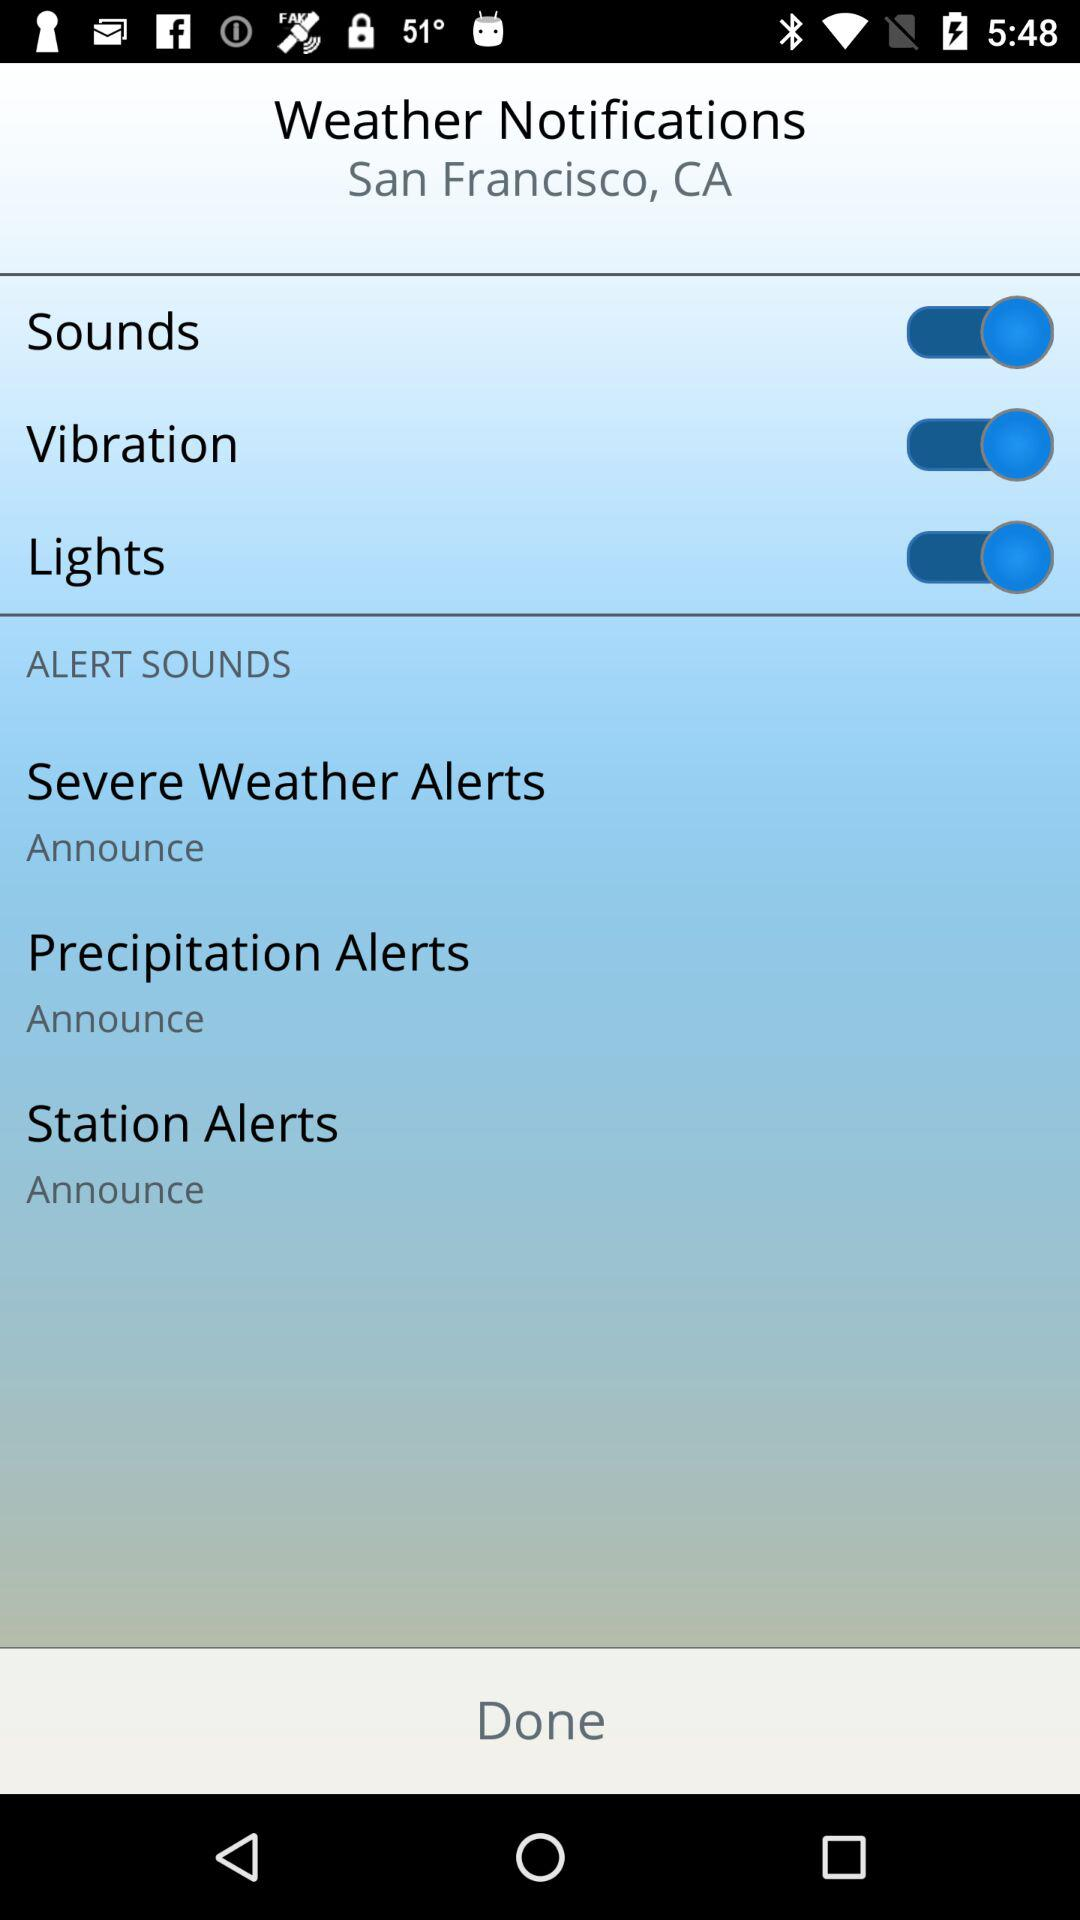What is the status of "Sounds"? The status of "Sounds" is "on". 